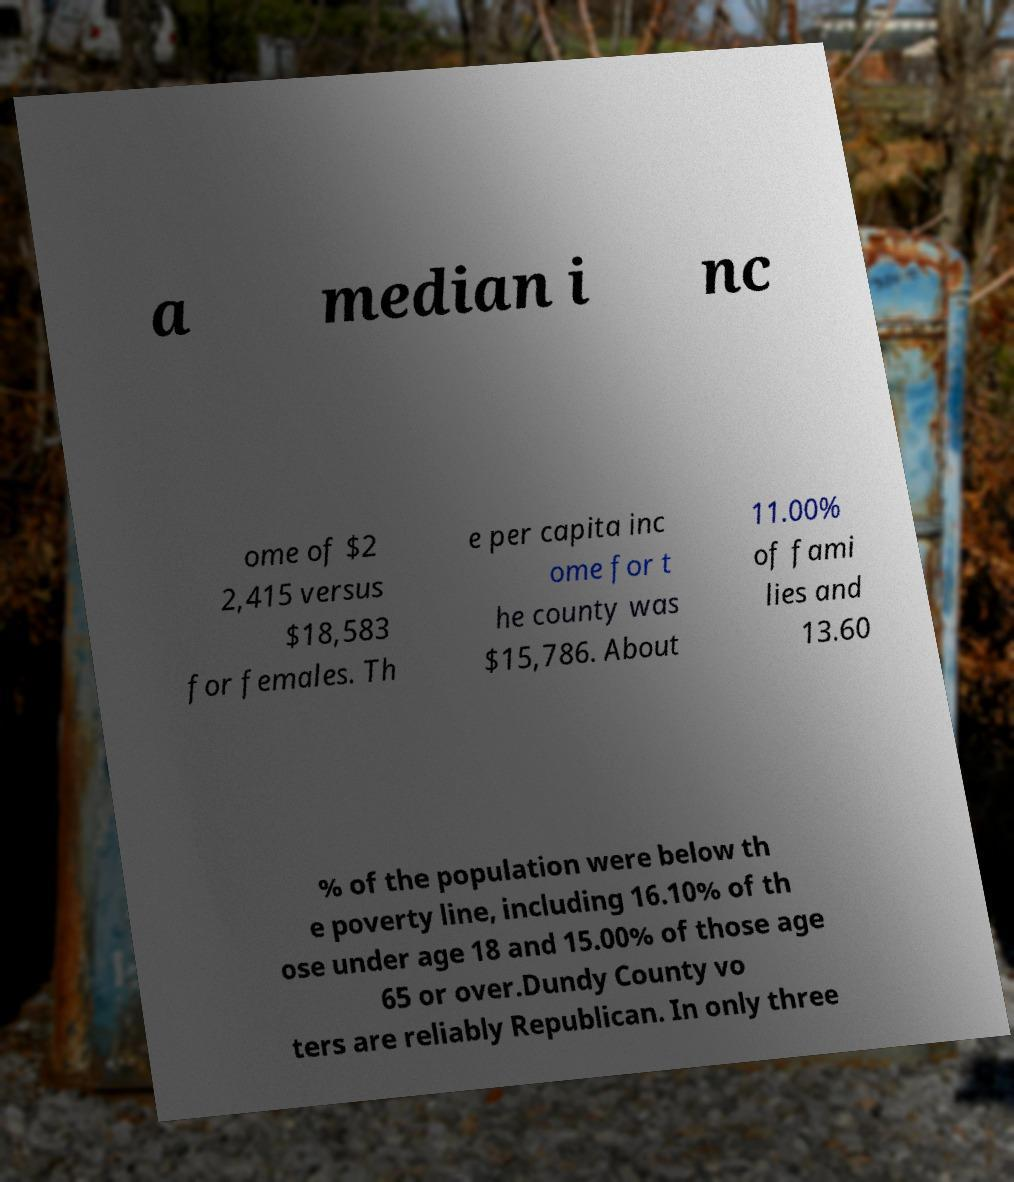Can you read and provide the text displayed in the image?This photo seems to have some interesting text. Can you extract and type it out for me? a median i nc ome of $2 2,415 versus $18,583 for females. Th e per capita inc ome for t he county was $15,786. About 11.00% of fami lies and 13.60 % of the population were below th e poverty line, including 16.10% of th ose under age 18 and 15.00% of those age 65 or over.Dundy County vo ters are reliably Republican. In only three 